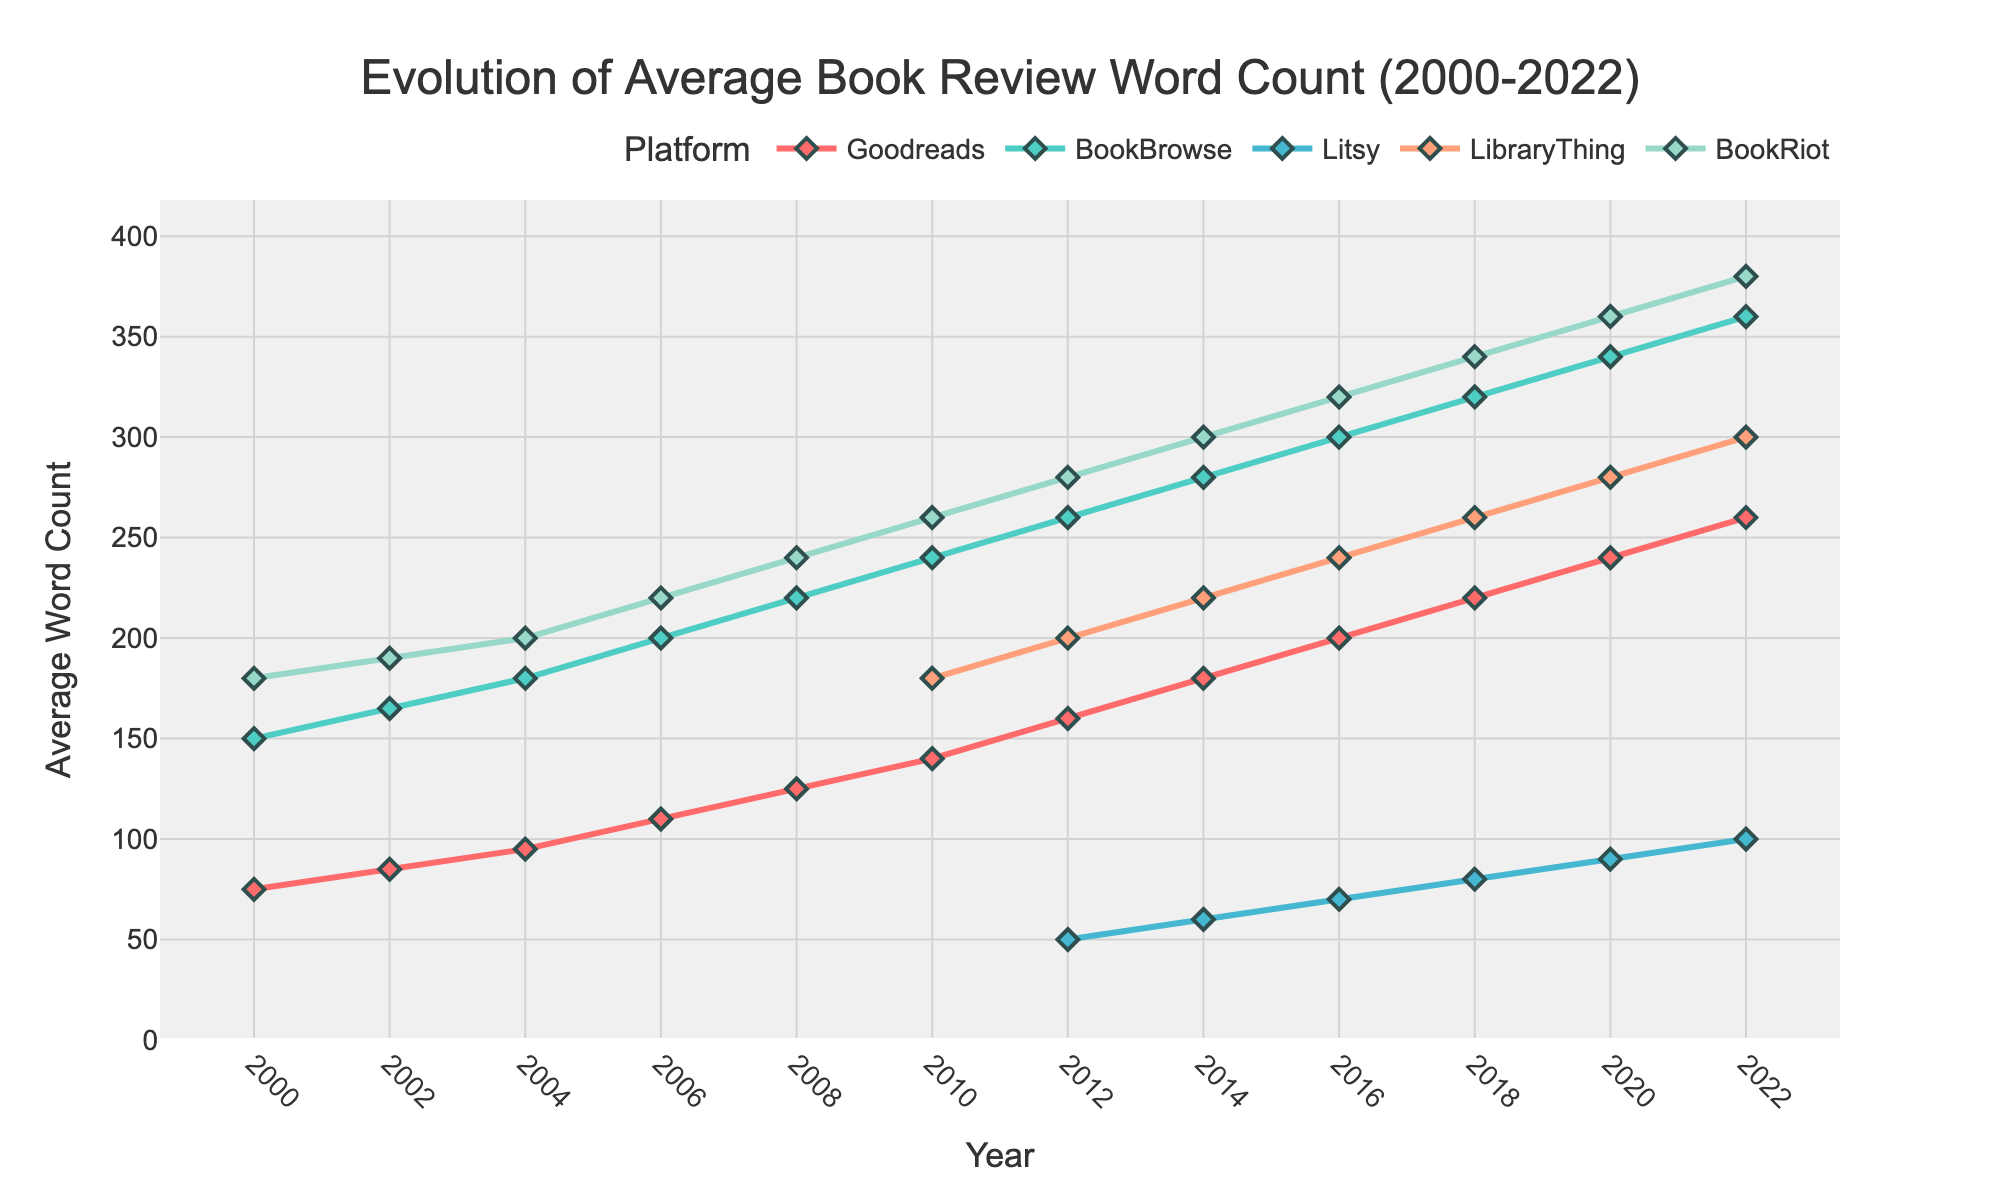What is the general trend in the average book review word count on Goodreads between 2000 and 2022? The word count on Goodreads consistently increases over the years, starting from 75 words in 2000 and reaching 260 words in 2022.
Answer: Increasing When did BookBrowse surpass 200 words in average book review word count? The average book review word count for BookBrowse surpassed 200 words in 2006, increasing from 180 words in 2004 to 200 words in 2006.
Answer: 2006 How does the average word count for Litsy in 2022 compare to Goodreads in 2000? In 2022, the average book review word count for Litsy is 100 words, while for Goodreads in 2000, it is 75 words. Therefore, Litsy in 2022 has 25 more words than Goodreads in 2000.
Answer: Litsy in 2022 has 25 more words Which platform experienced the largest increase in average word count from 2010 to 2022? By calculating the differences: Goodreads (120 words, from 140 to 260), BookBrowse (120 words, from 240 to 360), Litsy (50 words, from 50 to 100), LibraryThing (120 words, from 200 to 300), and BookRiot (120 words, from 260 to 380). All platforms except Litsy experienced an increase of 120 words.
Answer: Goodreads, BookBrowse, LibraryThing, and BookRiot In which year does BookBrowse's average review word count become higher than 300? The average book review word count for BookBrowse becomes higher than 300 in 2016, reaching 300 words exactly.
Answer: 2016 How many times does BookRiot's word count increase by 20 or more words between each recorded year? By observing the differences: 2000-2002 (10), 2002-2004 (10), 2004-2006 (20), 2006-2008 (20), 2008-2010 (20), 2010-2012 (20), 2012-2014 (20), 2014-2016 (20), 2016-2018 (20), 2018-2020 (20), and 2020-2022 (20). The word count increases by 20 or more words 8 times.
Answer: 8 times Which platform consistently has the highest average book review word count from 2010 to 2022? From 2010 to 2022, BookRiot has the highest average word counts: 260 (2010), 280 (2012), 300 (2014), 320 (2016), 340 (2018), 360 (2020), and 380 (2022).
Answer: BookRiot What is the difference between the average word count on LibraryThing and Litsy in 2018? In 2018, the average book review word count for LibraryThing is 260 words, and for Litsy, it is 80 words. The difference is 260 - 80 = 180 words.
Answer: 180 words Which platforms were included in the data starting from 2012? Platforms included in the data from 2012 are Goodreads, BookBrowse, Litsy, LibraryThing, and BookRiot.
Answer: Goodreads, BookBrowse, Litsy, LibraryThing, BookRiot 